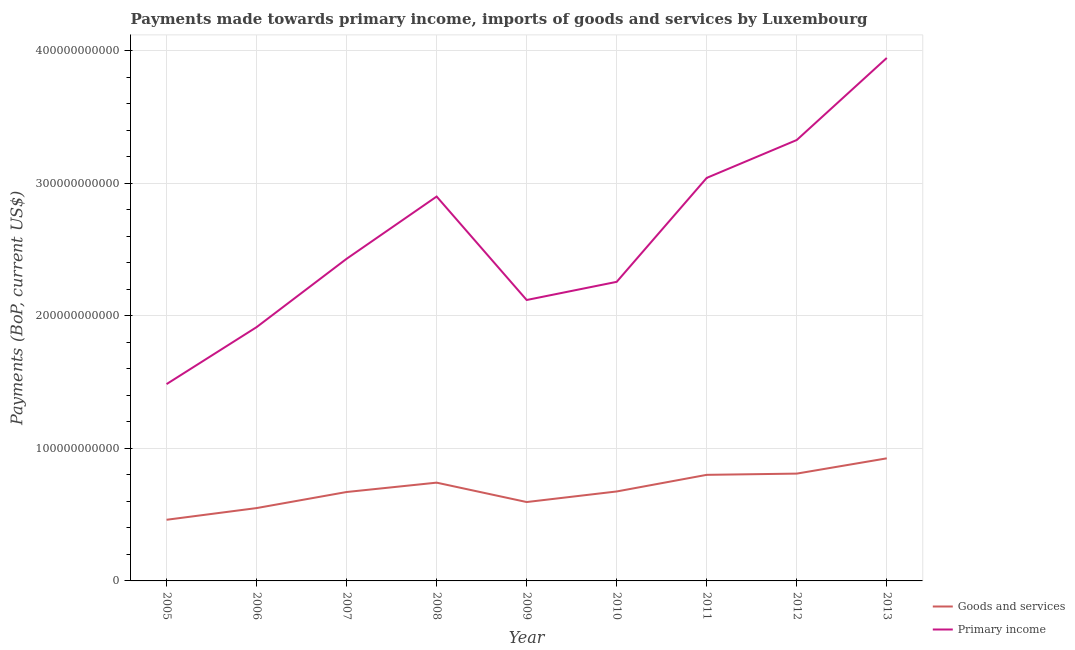How many different coloured lines are there?
Provide a short and direct response. 2. Is the number of lines equal to the number of legend labels?
Offer a terse response. Yes. What is the payments made towards goods and services in 2009?
Provide a succinct answer. 5.95e+1. Across all years, what is the maximum payments made towards primary income?
Make the answer very short. 3.94e+11. Across all years, what is the minimum payments made towards goods and services?
Your answer should be compact. 4.61e+1. In which year was the payments made towards goods and services maximum?
Make the answer very short. 2013. In which year was the payments made towards goods and services minimum?
Offer a very short reply. 2005. What is the total payments made towards goods and services in the graph?
Offer a terse response. 6.23e+11. What is the difference between the payments made towards goods and services in 2005 and that in 2010?
Ensure brevity in your answer.  -2.14e+1. What is the difference between the payments made towards primary income in 2007 and the payments made towards goods and services in 2010?
Your response must be concise. 1.76e+11. What is the average payments made towards primary income per year?
Ensure brevity in your answer.  2.60e+11. In the year 2011, what is the difference between the payments made towards goods and services and payments made towards primary income?
Your answer should be compact. -2.24e+11. What is the ratio of the payments made towards goods and services in 2008 to that in 2010?
Ensure brevity in your answer.  1.1. Is the payments made towards goods and services in 2008 less than that in 2011?
Your answer should be very brief. Yes. Is the difference between the payments made towards primary income in 2007 and 2013 greater than the difference between the payments made towards goods and services in 2007 and 2013?
Offer a very short reply. No. What is the difference between the highest and the second highest payments made towards primary income?
Provide a short and direct response. 6.19e+1. What is the difference between the highest and the lowest payments made towards primary income?
Give a very brief answer. 2.46e+11. In how many years, is the payments made towards goods and services greater than the average payments made towards goods and services taken over all years?
Give a very brief answer. 4. Does the payments made towards goods and services monotonically increase over the years?
Provide a short and direct response. No. Is the payments made towards primary income strictly greater than the payments made towards goods and services over the years?
Give a very brief answer. Yes. Is the payments made towards goods and services strictly less than the payments made towards primary income over the years?
Offer a terse response. Yes. What is the difference between two consecutive major ticks on the Y-axis?
Your response must be concise. 1.00e+11. Does the graph contain any zero values?
Offer a very short reply. No. Does the graph contain grids?
Offer a terse response. Yes. How are the legend labels stacked?
Ensure brevity in your answer.  Vertical. What is the title of the graph?
Offer a very short reply. Payments made towards primary income, imports of goods and services by Luxembourg. What is the label or title of the Y-axis?
Your response must be concise. Payments (BoP, current US$). What is the Payments (BoP, current US$) in Goods and services in 2005?
Ensure brevity in your answer.  4.61e+1. What is the Payments (BoP, current US$) of Primary income in 2005?
Your answer should be compact. 1.48e+11. What is the Payments (BoP, current US$) in Goods and services in 2006?
Your answer should be compact. 5.49e+1. What is the Payments (BoP, current US$) in Primary income in 2006?
Your answer should be compact. 1.91e+11. What is the Payments (BoP, current US$) in Goods and services in 2007?
Offer a terse response. 6.71e+1. What is the Payments (BoP, current US$) in Primary income in 2007?
Keep it short and to the point. 2.43e+11. What is the Payments (BoP, current US$) of Goods and services in 2008?
Provide a succinct answer. 7.41e+1. What is the Payments (BoP, current US$) of Primary income in 2008?
Ensure brevity in your answer.  2.90e+11. What is the Payments (BoP, current US$) in Goods and services in 2009?
Ensure brevity in your answer.  5.95e+1. What is the Payments (BoP, current US$) of Primary income in 2009?
Provide a short and direct response. 2.12e+11. What is the Payments (BoP, current US$) in Goods and services in 2010?
Ensure brevity in your answer.  6.75e+1. What is the Payments (BoP, current US$) of Primary income in 2010?
Keep it short and to the point. 2.26e+11. What is the Payments (BoP, current US$) in Goods and services in 2011?
Your answer should be compact. 8.00e+1. What is the Payments (BoP, current US$) in Primary income in 2011?
Ensure brevity in your answer.  3.04e+11. What is the Payments (BoP, current US$) of Goods and services in 2012?
Keep it short and to the point. 8.09e+1. What is the Payments (BoP, current US$) of Primary income in 2012?
Keep it short and to the point. 3.33e+11. What is the Payments (BoP, current US$) of Goods and services in 2013?
Your answer should be compact. 9.25e+1. What is the Payments (BoP, current US$) of Primary income in 2013?
Offer a very short reply. 3.94e+11. Across all years, what is the maximum Payments (BoP, current US$) in Goods and services?
Your response must be concise. 9.25e+1. Across all years, what is the maximum Payments (BoP, current US$) in Primary income?
Keep it short and to the point. 3.94e+11. Across all years, what is the minimum Payments (BoP, current US$) of Goods and services?
Offer a very short reply. 4.61e+1. Across all years, what is the minimum Payments (BoP, current US$) in Primary income?
Keep it short and to the point. 1.48e+11. What is the total Payments (BoP, current US$) of Goods and services in the graph?
Your answer should be very brief. 6.23e+11. What is the total Payments (BoP, current US$) of Primary income in the graph?
Provide a short and direct response. 2.34e+12. What is the difference between the Payments (BoP, current US$) in Goods and services in 2005 and that in 2006?
Your answer should be compact. -8.82e+09. What is the difference between the Payments (BoP, current US$) of Primary income in 2005 and that in 2006?
Your answer should be very brief. -4.30e+1. What is the difference between the Payments (BoP, current US$) in Goods and services in 2005 and that in 2007?
Offer a very short reply. -2.09e+1. What is the difference between the Payments (BoP, current US$) of Primary income in 2005 and that in 2007?
Your answer should be very brief. -9.45e+1. What is the difference between the Payments (BoP, current US$) in Goods and services in 2005 and that in 2008?
Your answer should be compact. -2.80e+1. What is the difference between the Payments (BoP, current US$) in Primary income in 2005 and that in 2008?
Keep it short and to the point. -1.41e+11. What is the difference between the Payments (BoP, current US$) of Goods and services in 2005 and that in 2009?
Ensure brevity in your answer.  -1.34e+1. What is the difference between the Payments (BoP, current US$) of Primary income in 2005 and that in 2009?
Provide a short and direct response. -6.34e+1. What is the difference between the Payments (BoP, current US$) in Goods and services in 2005 and that in 2010?
Give a very brief answer. -2.14e+1. What is the difference between the Payments (BoP, current US$) of Primary income in 2005 and that in 2010?
Provide a succinct answer. -7.71e+1. What is the difference between the Payments (BoP, current US$) of Goods and services in 2005 and that in 2011?
Keep it short and to the point. -3.39e+1. What is the difference between the Payments (BoP, current US$) in Primary income in 2005 and that in 2011?
Ensure brevity in your answer.  -1.56e+11. What is the difference between the Payments (BoP, current US$) in Goods and services in 2005 and that in 2012?
Give a very brief answer. -3.48e+1. What is the difference between the Payments (BoP, current US$) in Primary income in 2005 and that in 2012?
Provide a succinct answer. -1.84e+11. What is the difference between the Payments (BoP, current US$) in Goods and services in 2005 and that in 2013?
Your answer should be very brief. -4.63e+1. What is the difference between the Payments (BoP, current US$) in Primary income in 2005 and that in 2013?
Provide a short and direct response. -2.46e+11. What is the difference between the Payments (BoP, current US$) in Goods and services in 2006 and that in 2007?
Offer a very short reply. -1.21e+1. What is the difference between the Payments (BoP, current US$) of Primary income in 2006 and that in 2007?
Keep it short and to the point. -5.16e+1. What is the difference between the Payments (BoP, current US$) in Goods and services in 2006 and that in 2008?
Your response must be concise. -1.92e+1. What is the difference between the Payments (BoP, current US$) of Primary income in 2006 and that in 2008?
Offer a very short reply. -9.85e+1. What is the difference between the Payments (BoP, current US$) of Goods and services in 2006 and that in 2009?
Make the answer very short. -4.56e+09. What is the difference between the Payments (BoP, current US$) of Primary income in 2006 and that in 2009?
Offer a very short reply. -2.05e+1. What is the difference between the Payments (BoP, current US$) in Goods and services in 2006 and that in 2010?
Give a very brief answer. -1.25e+1. What is the difference between the Payments (BoP, current US$) of Primary income in 2006 and that in 2010?
Provide a short and direct response. -3.42e+1. What is the difference between the Payments (BoP, current US$) in Goods and services in 2006 and that in 2011?
Provide a short and direct response. -2.51e+1. What is the difference between the Payments (BoP, current US$) of Primary income in 2006 and that in 2011?
Offer a very short reply. -1.13e+11. What is the difference between the Payments (BoP, current US$) of Goods and services in 2006 and that in 2012?
Provide a short and direct response. -2.60e+1. What is the difference between the Payments (BoP, current US$) in Primary income in 2006 and that in 2012?
Your answer should be compact. -1.41e+11. What is the difference between the Payments (BoP, current US$) of Goods and services in 2006 and that in 2013?
Provide a succinct answer. -3.75e+1. What is the difference between the Payments (BoP, current US$) in Primary income in 2006 and that in 2013?
Offer a very short reply. -2.03e+11. What is the difference between the Payments (BoP, current US$) in Goods and services in 2007 and that in 2008?
Give a very brief answer. -7.06e+09. What is the difference between the Payments (BoP, current US$) in Primary income in 2007 and that in 2008?
Offer a terse response. -4.70e+1. What is the difference between the Payments (BoP, current US$) of Goods and services in 2007 and that in 2009?
Offer a terse response. 7.57e+09. What is the difference between the Payments (BoP, current US$) in Primary income in 2007 and that in 2009?
Offer a very short reply. 3.11e+1. What is the difference between the Payments (BoP, current US$) of Goods and services in 2007 and that in 2010?
Make the answer very short. -4.05e+08. What is the difference between the Payments (BoP, current US$) in Primary income in 2007 and that in 2010?
Offer a very short reply. 1.74e+1. What is the difference between the Payments (BoP, current US$) in Goods and services in 2007 and that in 2011?
Make the answer very short. -1.29e+1. What is the difference between the Payments (BoP, current US$) of Primary income in 2007 and that in 2011?
Keep it short and to the point. -6.10e+1. What is the difference between the Payments (BoP, current US$) in Goods and services in 2007 and that in 2012?
Give a very brief answer. -1.39e+1. What is the difference between the Payments (BoP, current US$) in Primary income in 2007 and that in 2012?
Make the answer very short. -8.96e+1. What is the difference between the Payments (BoP, current US$) of Goods and services in 2007 and that in 2013?
Your answer should be very brief. -2.54e+1. What is the difference between the Payments (BoP, current US$) of Primary income in 2007 and that in 2013?
Your answer should be very brief. -1.51e+11. What is the difference between the Payments (BoP, current US$) of Goods and services in 2008 and that in 2009?
Provide a succinct answer. 1.46e+1. What is the difference between the Payments (BoP, current US$) of Primary income in 2008 and that in 2009?
Your answer should be compact. 7.80e+1. What is the difference between the Payments (BoP, current US$) of Goods and services in 2008 and that in 2010?
Make the answer very short. 6.66e+09. What is the difference between the Payments (BoP, current US$) of Primary income in 2008 and that in 2010?
Your response must be concise. 6.43e+1. What is the difference between the Payments (BoP, current US$) of Goods and services in 2008 and that in 2011?
Ensure brevity in your answer.  -5.89e+09. What is the difference between the Payments (BoP, current US$) in Primary income in 2008 and that in 2011?
Make the answer very short. -1.41e+1. What is the difference between the Payments (BoP, current US$) in Goods and services in 2008 and that in 2012?
Give a very brief answer. -6.82e+09. What is the difference between the Payments (BoP, current US$) in Primary income in 2008 and that in 2012?
Provide a short and direct response. -4.26e+1. What is the difference between the Payments (BoP, current US$) in Goods and services in 2008 and that in 2013?
Your response must be concise. -1.83e+1. What is the difference between the Payments (BoP, current US$) in Primary income in 2008 and that in 2013?
Your answer should be very brief. -1.05e+11. What is the difference between the Payments (BoP, current US$) in Goods and services in 2009 and that in 2010?
Provide a short and direct response. -7.98e+09. What is the difference between the Payments (BoP, current US$) of Primary income in 2009 and that in 2010?
Provide a short and direct response. -1.37e+1. What is the difference between the Payments (BoP, current US$) in Goods and services in 2009 and that in 2011?
Your answer should be very brief. -2.05e+1. What is the difference between the Payments (BoP, current US$) in Primary income in 2009 and that in 2011?
Your answer should be very brief. -9.21e+1. What is the difference between the Payments (BoP, current US$) of Goods and services in 2009 and that in 2012?
Keep it short and to the point. -2.14e+1. What is the difference between the Payments (BoP, current US$) in Primary income in 2009 and that in 2012?
Provide a succinct answer. -1.21e+11. What is the difference between the Payments (BoP, current US$) of Goods and services in 2009 and that in 2013?
Offer a terse response. -3.30e+1. What is the difference between the Payments (BoP, current US$) of Primary income in 2009 and that in 2013?
Provide a short and direct response. -1.83e+11. What is the difference between the Payments (BoP, current US$) of Goods and services in 2010 and that in 2011?
Provide a short and direct response. -1.25e+1. What is the difference between the Payments (BoP, current US$) of Primary income in 2010 and that in 2011?
Offer a terse response. -7.84e+1. What is the difference between the Payments (BoP, current US$) in Goods and services in 2010 and that in 2012?
Your response must be concise. -1.35e+1. What is the difference between the Payments (BoP, current US$) of Primary income in 2010 and that in 2012?
Your answer should be compact. -1.07e+11. What is the difference between the Payments (BoP, current US$) in Goods and services in 2010 and that in 2013?
Provide a short and direct response. -2.50e+1. What is the difference between the Payments (BoP, current US$) of Primary income in 2010 and that in 2013?
Your response must be concise. -1.69e+11. What is the difference between the Payments (BoP, current US$) in Goods and services in 2011 and that in 2012?
Offer a terse response. -9.28e+08. What is the difference between the Payments (BoP, current US$) of Primary income in 2011 and that in 2012?
Provide a succinct answer. -2.86e+1. What is the difference between the Payments (BoP, current US$) of Goods and services in 2011 and that in 2013?
Give a very brief answer. -1.24e+1. What is the difference between the Payments (BoP, current US$) in Primary income in 2011 and that in 2013?
Your answer should be compact. -9.05e+1. What is the difference between the Payments (BoP, current US$) in Goods and services in 2012 and that in 2013?
Your response must be concise. -1.15e+1. What is the difference between the Payments (BoP, current US$) of Primary income in 2012 and that in 2013?
Offer a very short reply. -6.19e+1. What is the difference between the Payments (BoP, current US$) in Goods and services in 2005 and the Payments (BoP, current US$) in Primary income in 2006?
Give a very brief answer. -1.45e+11. What is the difference between the Payments (BoP, current US$) of Goods and services in 2005 and the Payments (BoP, current US$) of Primary income in 2007?
Keep it short and to the point. -1.97e+11. What is the difference between the Payments (BoP, current US$) in Goods and services in 2005 and the Payments (BoP, current US$) in Primary income in 2008?
Provide a succinct answer. -2.44e+11. What is the difference between the Payments (BoP, current US$) of Goods and services in 2005 and the Payments (BoP, current US$) of Primary income in 2009?
Keep it short and to the point. -1.66e+11. What is the difference between the Payments (BoP, current US$) of Goods and services in 2005 and the Payments (BoP, current US$) of Primary income in 2010?
Keep it short and to the point. -1.79e+11. What is the difference between the Payments (BoP, current US$) in Goods and services in 2005 and the Payments (BoP, current US$) in Primary income in 2011?
Provide a succinct answer. -2.58e+11. What is the difference between the Payments (BoP, current US$) in Goods and services in 2005 and the Payments (BoP, current US$) in Primary income in 2012?
Your answer should be very brief. -2.86e+11. What is the difference between the Payments (BoP, current US$) of Goods and services in 2005 and the Payments (BoP, current US$) of Primary income in 2013?
Ensure brevity in your answer.  -3.48e+11. What is the difference between the Payments (BoP, current US$) of Goods and services in 2006 and the Payments (BoP, current US$) of Primary income in 2007?
Give a very brief answer. -1.88e+11. What is the difference between the Payments (BoP, current US$) in Goods and services in 2006 and the Payments (BoP, current US$) in Primary income in 2008?
Ensure brevity in your answer.  -2.35e+11. What is the difference between the Payments (BoP, current US$) of Goods and services in 2006 and the Payments (BoP, current US$) of Primary income in 2009?
Offer a terse response. -1.57e+11. What is the difference between the Payments (BoP, current US$) of Goods and services in 2006 and the Payments (BoP, current US$) of Primary income in 2010?
Provide a short and direct response. -1.71e+11. What is the difference between the Payments (BoP, current US$) in Goods and services in 2006 and the Payments (BoP, current US$) in Primary income in 2011?
Your response must be concise. -2.49e+11. What is the difference between the Payments (BoP, current US$) of Goods and services in 2006 and the Payments (BoP, current US$) of Primary income in 2012?
Give a very brief answer. -2.78e+11. What is the difference between the Payments (BoP, current US$) of Goods and services in 2006 and the Payments (BoP, current US$) of Primary income in 2013?
Give a very brief answer. -3.40e+11. What is the difference between the Payments (BoP, current US$) in Goods and services in 2007 and the Payments (BoP, current US$) in Primary income in 2008?
Make the answer very short. -2.23e+11. What is the difference between the Payments (BoP, current US$) in Goods and services in 2007 and the Payments (BoP, current US$) in Primary income in 2009?
Your answer should be compact. -1.45e+11. What is the difference between the Payments (BoP, current US$) of Goods and services in 2007 and the Payments (BoP, current US$) of Primary income in 2010?
Keep it short and to the point. -1.59e+11. What is the difference between the Payments (BoP, current US$) of Goods and services in 2007 and the Payments (BoP, current US$) of Primary income in 2011?
Give a very brief answer. -2.37e+11. What is the difference between the Payments (BoP, current US$) in Goods and services in 2007 and the Payments (BoP, current US$) in Primary income in 2012?
Your answer should be compact. -2.66e+11. What is the difference between the Payments (BoP, current US$) of Goods and services in 2007 and the Payments (BoP, current US$) of Primary income in 2013?
Keep it short and to the point. -3.27e+11. What is the difference between the Payments (BoP, current US$) in Goods and services in 2008 and the Payments (BoP, current US$) in Primary income in 2009?
Provide a succinct answer. -1.38e+11. What is the difference between the Payments (BoP, current US$) of Goods and services in 2008 and the Payments (BoP, current US$) of Primary income in 2010?
Your answer should be very brief. -1.51e+11. What is the difference between the Payments (BoP, current US$) in Goods and services in 2008 and the Payments (BoP, current US$) in Primary income in 2011?
Your response must be concise. -2.30e+11. What is the difference between the Payments (BoP, current US$) of Goods and services in 2008 and the Payments (BoP, current US$) of Primary income in 2012?
Your response must be concise. -2.58e+11. What is the difference between the Payments (BoP, current US$) in Goods and services in 2008 and the Payments (BoP, current US$) in Primary income in 2013?
Offer a very short reply. -3.20e+11. What is the difference between the Payments (BoP, current US$) in Goods and services in 2009 and the Payments (BoP, current US$) in Primary income in 2010?
Offer a very short reply. -1.66e+11. What is the difference between the Payments (BoP, current US$) in Goods and services in 2009 and the Payments (BoP, current US$) in Primary income in 2011?
Provide a short and direct response. -2.45e+11. What is the difference between the Payments (BoP, current US$) of Goods and services in 2009 and the Payments (BoP, current US$) of Primary income in 2012?
Give a very brief answer. -2.73e+11. What is the difference between the Payments (BoP, current US$) of Goods and services in 2009 and the Payments (BoP, current US$) of Primary income in 2013?
Keep it short and to the point. -3.35e+11. What is the difference between the Payments (BoP, current US$) in Goods and services in 2010 and the Payments (BoP, current US$) in Primary income in 2011?
Ensure brevity in your answer.  -2.37e+11. What is the difference between the Payments (BoP, current US$) in Goods and services in 2010 and the Payments (BoP, current US$) in Primary income in 2012?
Provide a short and direct response. -2.65e+11. What is the difference between the Payments (BoP, current US$) of Goods and services in 2010 and the Payments (BoP, current US$) of Primary income in 2013?
Keep it short and to the point. -3.27e+11. What is the difference between the Payments (BoP, current US$) of Goods and services in 2011 and the Payments (BoP, current US$) of Primary income in 2012?
Provide a short and direct response. -2.53e+11. What is the difference between the Payments (BoP, current US$) of Goods and services in 2011 and the Payments (BoP, current US$) of Primary income in 2013?
Your answer should be compact. -3.14e+11. What is the difference between the Payments (BoP, current US$) in Goods and services in 2012 and the Payments (BoP, current US$) in Primary income in 2013?
Keep it short and to the point. -3.14e+11. What is the average Payments (BoP, current US$) in Goods and services per year?
Provide a succinct answer. 6.92e+1. What is the average Payments (BoP, current US$) of Primary income per year?
Your answer should be compact. 2.60e+11. In the year 2005, what is the difference between the Payments (BoP, current US$) in Goods and services and Payments (BoP, current US$) in Primary income?
Keep it short and to the point. -1.02e+11. In the year 2006, what is the difference between the Payments (BoP, current US$) in Goods and services and Payments (BoP, current US$) in Primary income?
Provide a short and direct response. -1.36e+11. In the year 2007, what is the difference between the Payments (BoP, current US$) in Goods and services and Payments (BoP, current US$) in Primary income?
Give a very brief answer. -1.76e+11. In the year 2008, what is the difference between the Payments (BoP, current US$) of Goods and services and Payments (BoP, current US$) of Primary income?
Make the answer very short. -2.16e+11. In the year 2009, what is the difference between the Payments (BoP, current US$) of Goods and services and Payments (BoP, current US$) of Primary income?
Offer a very short reply. -1.52e+11. In the year 2010, what is the difference between the Payments (BoP, current US$) in Goods and services and Payments (BoP, current US$) in Primary income?
Provide a succinct answer. -1.58e+11. In the year 2011, what is the difference between the Payments (BoP, current US$) of Goods and services and Payments (BoP, current US$) of Primary income?
Your answer should be compact. -2.24e+11. In the year 2012, what is the difference between the Payments (BoP, current US$) in Goods and services and Payments (BoP, current US$) in Primary income?
Ensure brevity in your answer.  -2.52e+11. In the year 2013, what is the difference between the Payments (BoP, current US$) in Goods and services and Payments (BoP, current US$) in Primary income?
Make the answer very short. -3.02e+11. What is the ratio of the Payments (BoP, current US$) in Goods and services in 2005 to that in 2006?
Offer a terse response. 0.84. What is the ratio of the Payments (BoP, current US$) in Primary income in 2005 to that in 2006?
Offer a terse response. 0.78. What is the ratio of the Payments (BoP, current US$) in Goods and services in 2005 to that in 2007?
Provide a short and direct response. 0.69. What is the ratio of the Payments (BoP, current US$) in Primary income in 2005 to that in 2007?
Make the answer very short. 0.61. What is the ratio of the Payments (BoP, current US$) in Goods and services in 2005 to that in 2008?
Your response must be concise. 0.62. What is the ratio of the Payments (BoP, current US$) of Primary income in 2005 to that in 2008?
Offer a terse response. 0.51. What is the ratio of the Payments (BoP, current US$) in Goods and services in 2005 to that in 2009?
Ensure brevity in your answer.  0.78. What is the ratio of the Payments (BoP, current US$) of Primary income in 2005 to that in 2009?
Provide a succinct answer. 0.7. What is the ratio of the Payments (BoP, current US$) in Goods and services in 2005 to that in 2010?
Offer a terse response. 0.68. What is the ratio of the Payments (BoP, current US$) in Primary income in 2005 to that in 2010?
Your answer should be very brief. 0.66. What is the ratio of the Payments (BoP, current US$) of Goods and services in 2005 to that in 2011?
Keep it short and to the point. 0.58. What is the ratio of the Payments (BoP, current US$) of Primary income in 2005 to that in 2011?
Your response must be concise. 0.49. What is the ratio of the Payments (BoP, current US$) of Goods and services in 2005 to that in 2012?
Provide a succinct answer. 0.57. What is the ratio of the Payments (BoP, current US$) of Primary income in 2005 to that in 2012?
Offer a very short reply. 0.45. What is the ratio of the Payments (BoP, current US$) of Goods and services in 2005 to that in 2013?
Make the answer very short. 0.5. What is the ratio of the Payments (BoP, current US$) of Primary income in 2005 to that in 2013?
Your answer should be very brief. 0.38. What is the ratio of the Payments (BoP, current US$) of Goods and services in 2006 to that in 2007?
Provide a short and direct response. 0.82. What is the ratio of the Payments (BoP, current US$) of Primary income in 2006 to that in 2007?
Your response must be concise. 0.79. What is the ratio of the Payments (BoP, current US$) in Goods and services in 2006 to that in 2008?
Ensure brevity in your answer.  0.74. What is the ratio of the Payments (BoP, current US$) of Primary income in 2006 to that in 2008?
Ensure brevity in your answer.  0.66. What is the ratio of the Payments (BoP, current US$) in Goods and services in 2006 to that in 2009?
Provide a succinct answer. 0.92. What is the ratio of the Payments (BoP, current US$) of Primary income in 2006 to that in 2009?
Give a very brief answer. 0.9. What is the ratio of the Payments (BoP, current US$) of Goods and services in 2006 to that in 2010?
Offer a very short reply. 0.81. What is the ratio of the Payments (BoP, current US$) of Primary income in 2006 to that in 2010?
Give a very brief answer. 0.85. What is the ratio of the Payments (BoP, current US$) of Goods and services in 2006 to that in 2011?
Your answer should be very brief. 0.69. What is the ratio of the Payments (BoP, current US$) in Primary income in 2006 to that in 2011?
Your answer should be very brief. 0.63. What is the ratio of the Payments (BoP, current US$) in Goods and services in 2006 to that in 2012?
Provide a short and direct response. 0.68. What is the ratio of the Payments (BoP, current US$) of Primary income in 2006 to that in 2012?
Offer a terse response. 0.58. What is the ratio of the Payments (BoP, current US$) in Goods and services in 2006 to that in 2013?
Your answer should be very brief. 0.59. What is the ratio of the Payments (BoP, current US$) in Primary income in 2006 to that in 2013?
Offer a terse response. 0.49. What is the ratio of the Payments (BoP, current US$) in Goods and services in 2007 to that in 2008?
Ensure brevity in your answer.  0.9. What is the ratio of the Payments (BoP, current US$) of Primary income in 2007 to that in 2008?
Make the answer very short. 0.84. What is the ratio of the Payments (BoP, current US$) of Goods and services in 2007 to that in 2009?
Make the answer very short. 1.13. What is the ratio of the Payments (BoP, current US$) of Primary income in 2007 to that in 2009?
Offer a terse response. 1.15. What is the ratio of the Payments (BoP, current US$) in Primary income in 2007 to that in 2010?
Give a very brief answer. 1.08. What is the ratio of the Payments (BoP, current US$) of Goods and services in 2007 to that in 2011?
Provide a succinct answer. 0.84. What is the ratio of the Payments (BoP, current US$) of Primary income in 2007 to that in 2011?
Your response must be concise. 0.8. What is the ratio of the Payments (BoP, current US$) of Goods and services in 2007 to that in 2012?
Provide a succinct answer. 0.83. What is the ratio of the Payments (BoP, current US$) of Primary income in 2007 to that in 2012?
Give a very brief answer. 0.73. What is the ratio of the Payments (BoP, current US$) of Goods and services in 2007 to that in 2013?
Offer a terse response. 0.73. What is the ratio of the Payments (BoP, current US$) of Primary income in 2007 to that in 2013?
Offer a very short reply. 0.62. What is the ratio of the Payments (BoP, current US$) in Goods and services in 2008 to that in 2009?
Your answer should be compact. 1.25. What is the ratio of the Payments (BoP, current US$) in Primary income in 2008 to that in 2009?
Your answer should be very brief. 1.37. What is the ratio of the Payments (BoP, current US$) of Goods and services in 2008 to that in 2010?
Your response must be concise. 1.1. What is the ratio of the Payments (BoP, current US$) of Primary income in 2008 to that in 2010?
Provide a short and direct response. 1.29. What is the ratio of the Payments (BoP, current US$) of Goods and services in 2008 to that in 2011?
Give a very brief answer. 0.93. What is the ratio of the Payments (BoP, current US$) of Primary income in 2008 to that in 2011?
Make the answer very short. 0.95. What is the ratio of the Payments (BoP, current US$) in Goods and services in 2008 to that in 2012?
Provide a short and direct response. 0.92. What is the ratio of the Payments (BoP, current US$) in Primary income in 2008 to that in 2012?
Your response must be concise. 0.87. What is the ratio of the Payments (BoP, current US$) of Goods and services in 2008 to that in 2013?
Provide a short and direct response. 0.8. What is the ratio of the Payments (BoP, current US$) of Primary income in 2008 to that in 2013?
Keep it short and to the point. 0.73. What is the ratio of the Payments (BoP, current US$) of Goods and services in 2009 to that in 2010?
Provide a succinct answer. 0.88. What is the ratio of the Payments (BoP, current US$) in Primary income in 2009 to that in 2010?
Your answer should be compact. 0.94. What is the ratio of the Payments (BoP, current US$) of Goods and services in 2009 to that in 2011?
Your response must be concise. 0.74. What is the ratio of the Payments (BoP, current US$) of Primary income in 2009 to that in 2011?
Offer a very short reply. 0.7. What is the ratio of the Payments (BoP, current US$) of Goods and services in 2009 to that in 2012?
Offer a very short reply. 0.73. What is the ratio of the Payments (BoP, current US$) of Primary income in 2009 to that in 2012?
Your response must be concise. 0.64. What is the ratio of the Payments (BoP, current US$) of Goods and services in 2009 to that in 2013?
Make the answer very short. 0.64. What is the ratio of the Payments (BoP, current US$) in Primary income in 2009 to that in 2013?
Give a very brief answer. 0.54. What is the ratio of the Payments (BoP, current US$) of Goods and services in 2010 to that in 2011?
Give a very brief answer. 0.84. What is the ratio of the Payments (BoP, current US$) of Primary income in 2010 to that in 2011?
Offer a terse response. 0.74. What is the ratio of the Payments (BoP, current US$) in Goods and services in 2010 to that in 2012?
Your answer should be compact. 0.83. What is the ratio of the Payments (BoP, current US$) of Primary income in 2010 to that in 2012?
Keep it short and to the point. 0.68. What is the ratio of the Payments (BoP, current US$) of Goods and services in 2010 to that in 2013?
Ensure brevity in your answer.  0.73. What is the ratio of the Payments (BoP, current US$) of Primary income in 2010 to that in 2013?
Provide a succinct answer. 0.57. What is the ratio of the Payments (BoP, current US$) of Goods and services in 2011 to that in 2012?
Make the answer very short. 0.99. What is the ratio of the Payments (BoP, current US$) of Primary income in 2011 to that in 2012?
Make the answer very short. 0.91. What is the ratio of the Payments (BoP, current US$) of Goods and services in 2011 to that in 2013?
Your answer should be very brief. 0.87. What is the ratio of the Payments (BoP, current US$) of Primary income in 2011 to that in 2013?
Your answer should be very brief. 0.77. What is the ratio of the Payments (BoP, current US$) in Goods and services in 2012 to that in 2013?
Your answer should be very brief. 0.88. What is the ratio of the Payments (BoP, current US$) of Primary income in 2012 to that in 2013?
Keep it short and to the point. 0.84. What is the difference between the highest and the second highest Payments (BoP, current US$) of Goods and services?
Your response must be concise. 1.15e+1. What is the difference between the highest and the second highest Payments (BoP, current US$) in Primary income?
Your response must be concise. 6.19e+1. What is the difference between the highest and the lowest Payments (BoP, current US$) of Goods and services?
Your response must be concise. 4.63e+1. What is the difference between the highest and the lowest Payments (BoP, current US$) in Primary income?
Your answer should be compact. 2.46e+11. 